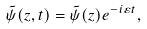<formula> <loc_0><loc_0><loc_500><loc_500>\tilde { \psi } ( z , t ) = \tilde { \psi } ( z ) e ^ { - i \varepsilon t } ,</formula> 